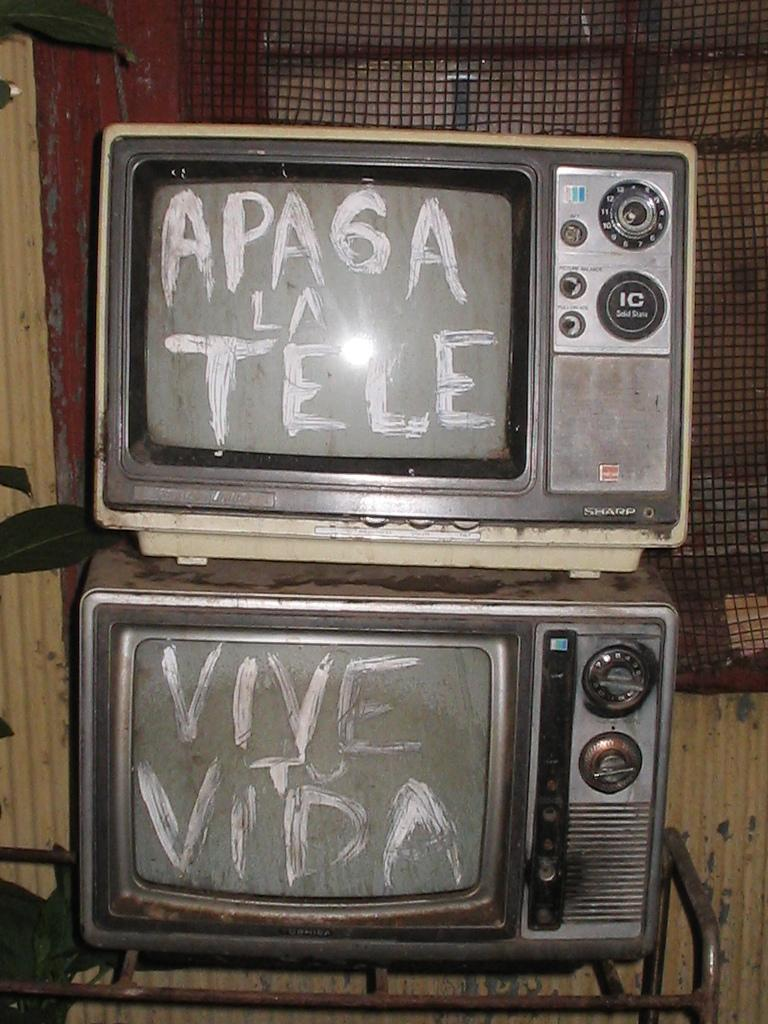<image>
Render a clear and concise summary of the photo. Old television sets have writing on them in white, including the word "VIDA." 